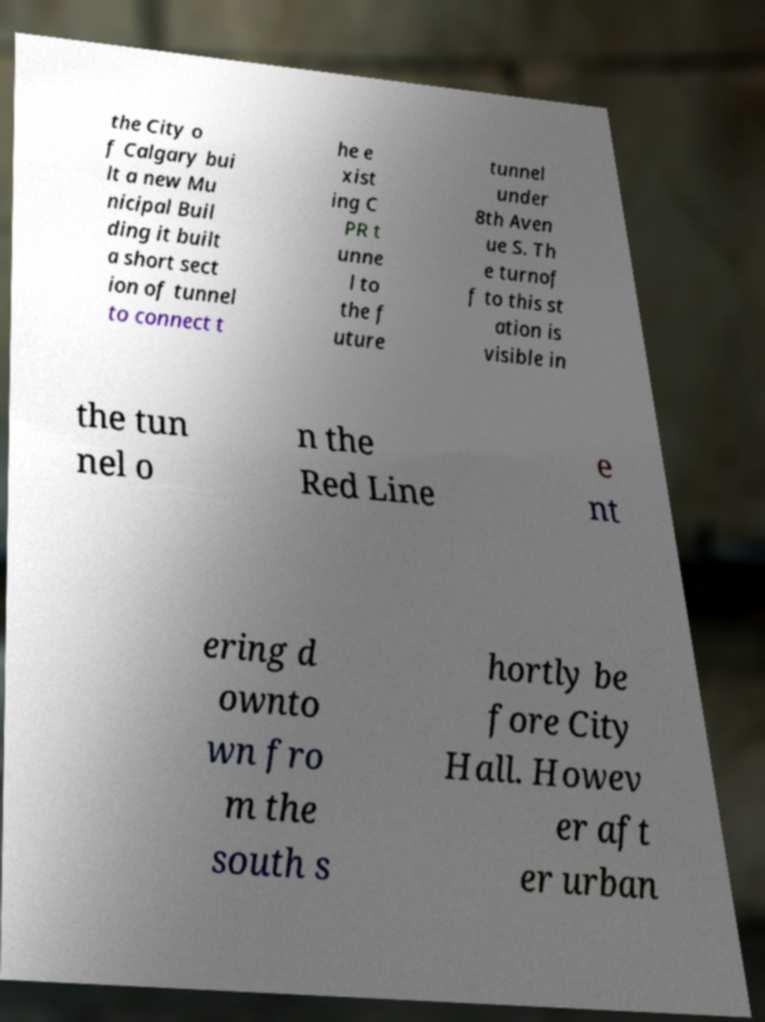Could you extract and type out the text from this image? the City o f Calgary bui lt a new Mu nicipal Buil ding it built a short sect ion of tunnel to connect t he e xist ing C PR t unne l to the f uture tunnel under 8th Aven ue S. Th e turnof f to this st ation is visible in the tun nel o n the Red Line e nt ering d ownto wn fro m the south s hortly be fore City Hall. Howev er aft er urban 